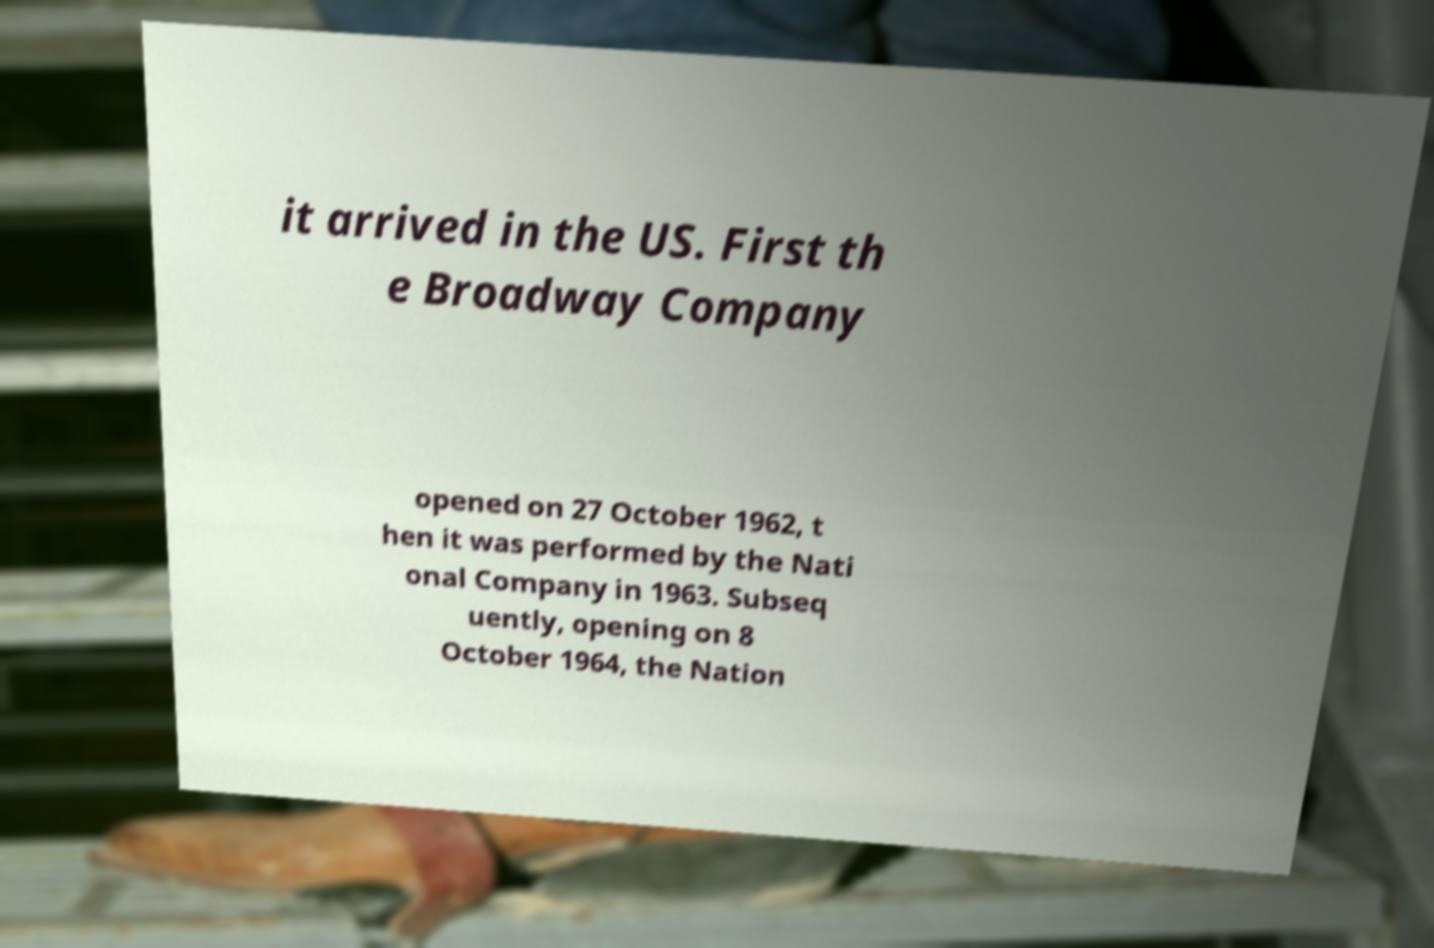Could you assist in decoding the text presented in this image and type it out clearly? it arrived in the US. First th e Broadway Company opened on 27 October 1962, t hen it was performed by the Nati onal Company in 1963. Subseq uently, opening on 8 October 1964, the Nation 